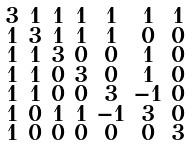Convert formula to latex. <formula><loc_0><loc_0><loc_500><loc_500>\begin{smallmatrix} 3 & 1 & 1 & 1 & 1 & 1 & 1 \\ 1 & 3 & 1 & 1 & 1 & 0 & 0 \\ 1 & 1 & 3 & 0 & 0 & 1 & 0 \\ 1 & 1 & 0 & 3 & 0 & 1 & 0 \\ 1 & 1 & 0 & 0 & 3 & - 1 & 0 \\ 1 & 0 & 1 & 1 & - 1 & 3 & 0 \\ 1 & 0 & 0 & 0 & 0 & 0 & 3 \end{smallmatrix}</formula> 